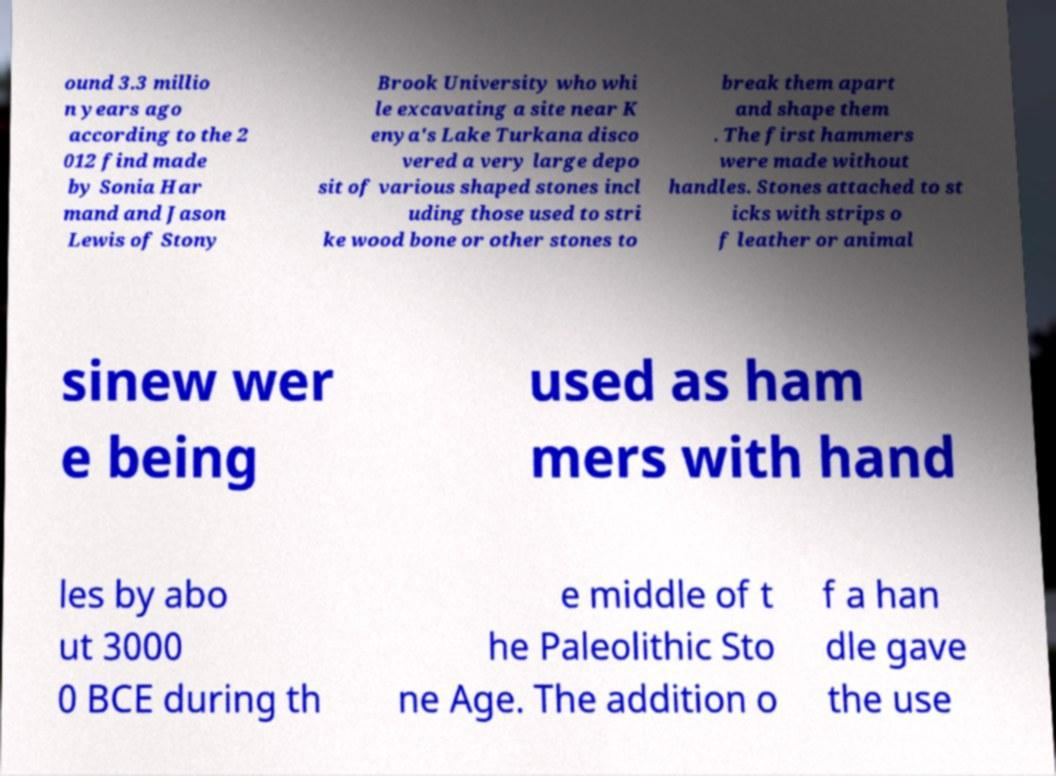Can you read and provide the text displayed in the image?This photo seems to have some interesting text. Can you extract and type it out for me? ound 3.3 millio n years ago according to the 2 012 find made by Sonia Har mand and Jason Lewis of Stony Brook University who whi le excavating a site near K enya's Lake Turkana disco vered a very large depo sit of various shaped stones incl uding those used to stri ke wood bone or other stones to break them apart and shape them . The first hammers were made without handles. Stones attached to st icks with strips o f leather or animal sinew wer e being used as ham mers with hand les by abo ut 3000 0 BCE during th e middle of t he Paleolithic Sto ne Age. The addition o f a han dle gave the use 